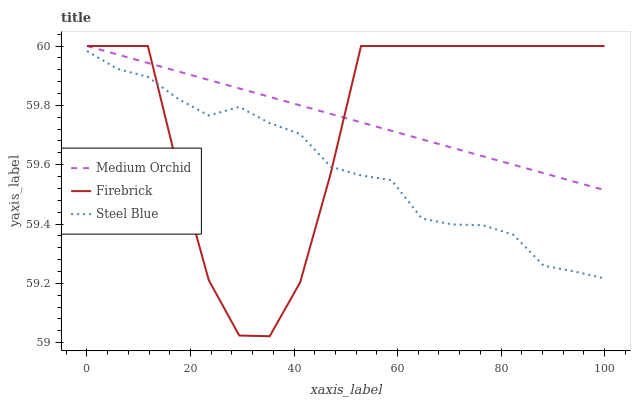Does Steel Blue have the minimum area under the curve?
Answer yes or no. Yes. Does Medium Orchid have the maximum area under the curve?
Answer yes or no. Yes. Does Medium Orchid have the minimum area under the curve?
Answer yes or no. No. Does Steel Blue have the maximum area under the curve?
Answer yes or no. No. Is Medium Orchid the smoothest?
Answer yes or no. Yes. Is Firebrick the roughest?
Answer yes or no. Yes. Is Steel Blue the smoothest?
Answer yes or no. No. Is Steel Blue the roughest?
Answer yes or no. No. Does Firebrick have the lowest value?
Answer yes or no. Yes. Does Steel Blue have the lowest value?
Answer yes or no. No. Does Medium Orchid have the highest value?
Answer yes or no. Yes. Does Steel Blue have the highest value?
Answer yes or no. No. Is Steel Blue less than Medium Orchid?
Answer yes or no. Yes. Is Medium Orchid greater than Steel Blue?
Answer yes or no. Yes. Does Steel Blue intersect Firebrick?
Answer yes or no. Yes. Is Steel Blue less than Firebrick?
Answer yes or no. No. Is Steel Blue greater than Firebrick?
Answer yes or no. No. Does Steel Blue intersect Medium Orchid?
Answer yes or no. No. 